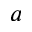<formula> <loc_0><loc_0><loc_500><loc_500>a</formula> 